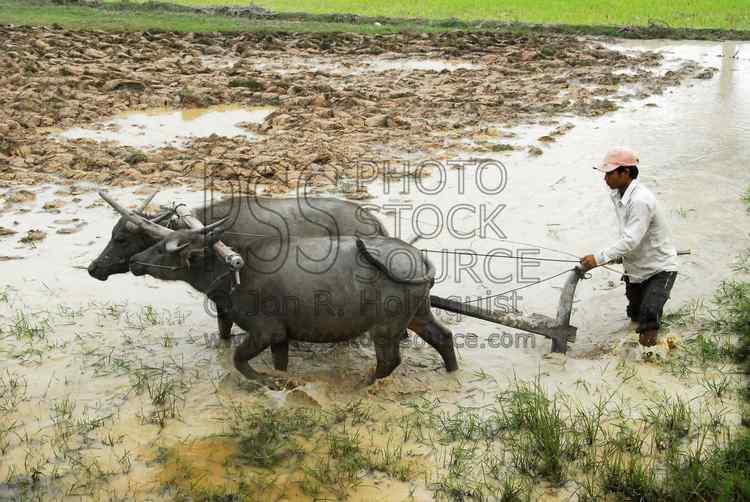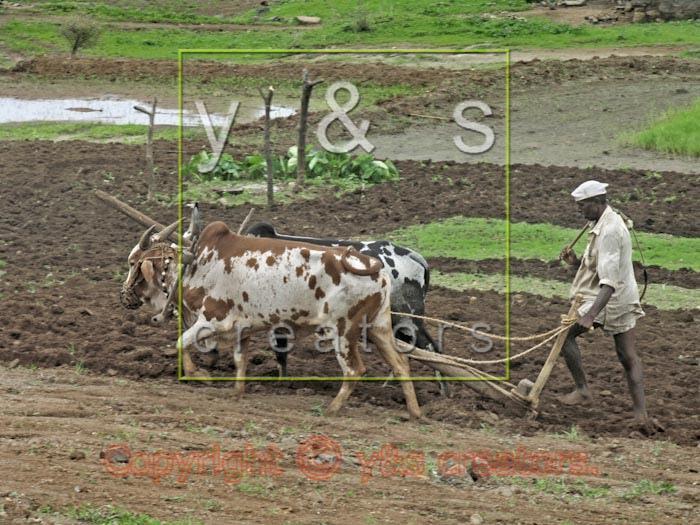The first image is the image on the left, the second image is the image on the right. For the images shown, is this caption "In one of the images there are 2 people wearing a hat." true? Answer yes or no. No. The first image is the image on the left, the second image is the image on the right. Analyze the images presented: Is the assertion "One image includes two spotted oxen pulling a plow, and the other image shows a plow team with at least two solid black oxen." valid? Answer yes or no. Yes. 